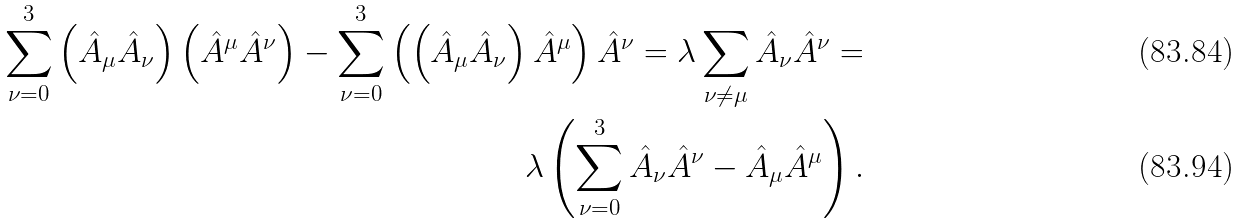<formula> <loc_0><loc_0><loc_500><loc_500>\sum ^ { 3 } _ { \nu = 0 } \left ( \hat { A } _ { \mu } \hat { A } _ { \nu } \right ) \left ( \hat { A } ^ { \mu } \hat { A } ^ { \nu } \right ) - \sum ^ { 3 } _ { \nu = 0 } \left ( \left ( \hat { A } _ { \mu } \hat { A } _ { \nu } \right ) \hat { A } ^ { \mu } \right ) \hat { A } ^ { \nu } = \lambda \sum _ { \nu \neq \mu } \hat { A } _ { \nu } \hat { A } ^ { \nu } = \\ \lambda \left ( \sum ^ { 3 } _ { \nu = 0 } \hat { A } _ { \nu } \hat { A } ^ { \nu } - \hat { A } _ { \mu } \hat { A } ^ { \mu } \right ) .</formula> 